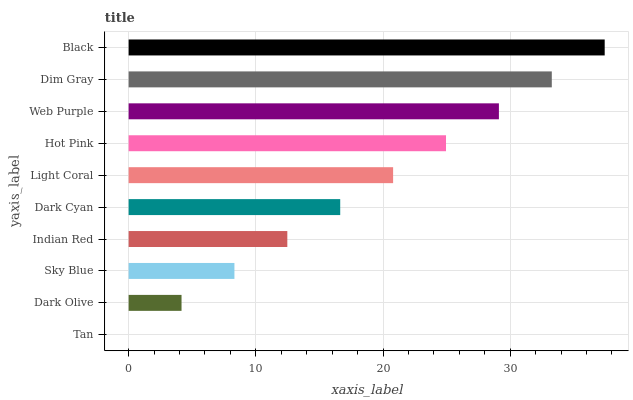Is Tan the minimum?
Answer yes or no. Yes. Is Black the maximum?
Answer yes or no. Yes. Is Dark Olive the minimum?
Answer yes or no. No. Is Dark Olive the maximum?
Answer yes or no. No. Is Dark Olive greater than Tan?
Answer yes or no. Yes. Is Tan less than Dark Olive?
Answer yes or no. Yes. Is Tan greater than Dark Olive?
Answer yes or no. No. Is Dark Olive less than Tan?
Answer yes or no. No. Is Light Coral the high median?
Answer yes or no. Yes. Is Dark Cyan the low median?
Answer yes or no. Yes. Is Dark Cyan the high median?
Answer yes or no. No. Is Dim Gray the low median?
Answer yes or no. No. 